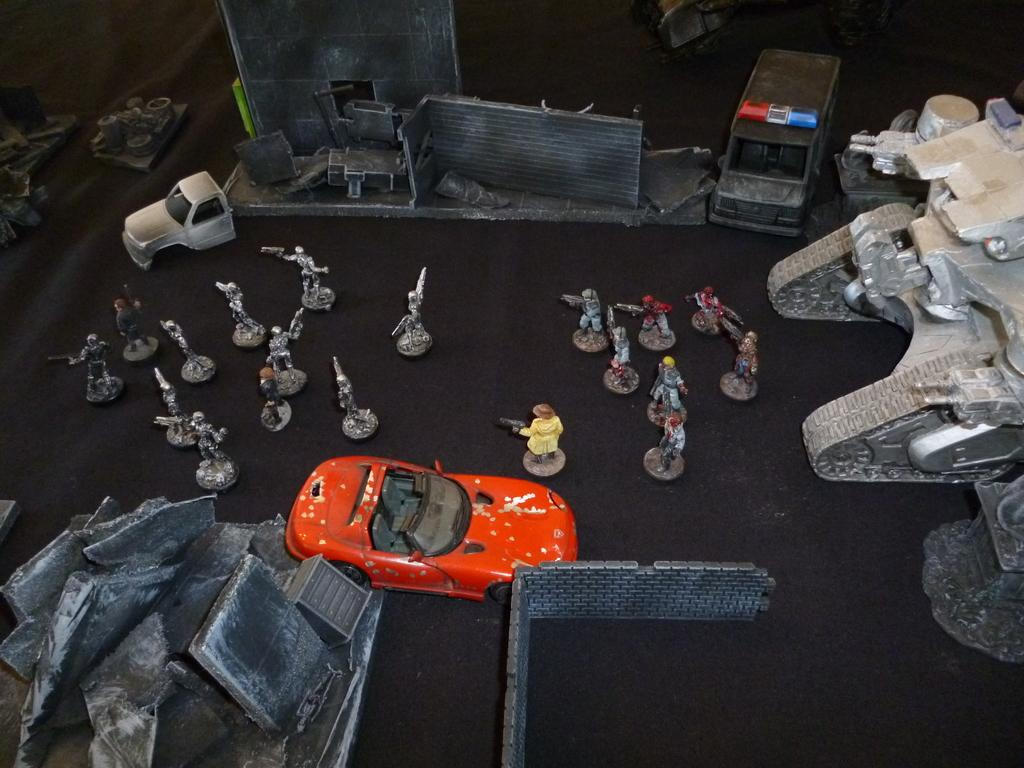What is the color of the toy car in the image? The toy car in the image is red. What else can be seen in the image besides the toy car? There are other toys in the image. What is the color of the surface on which the toys are placed? The toys are placed on a black color surface. Is there a watch visible on the black surface in the image? No, there is no watch visible on the black surface in the image. 